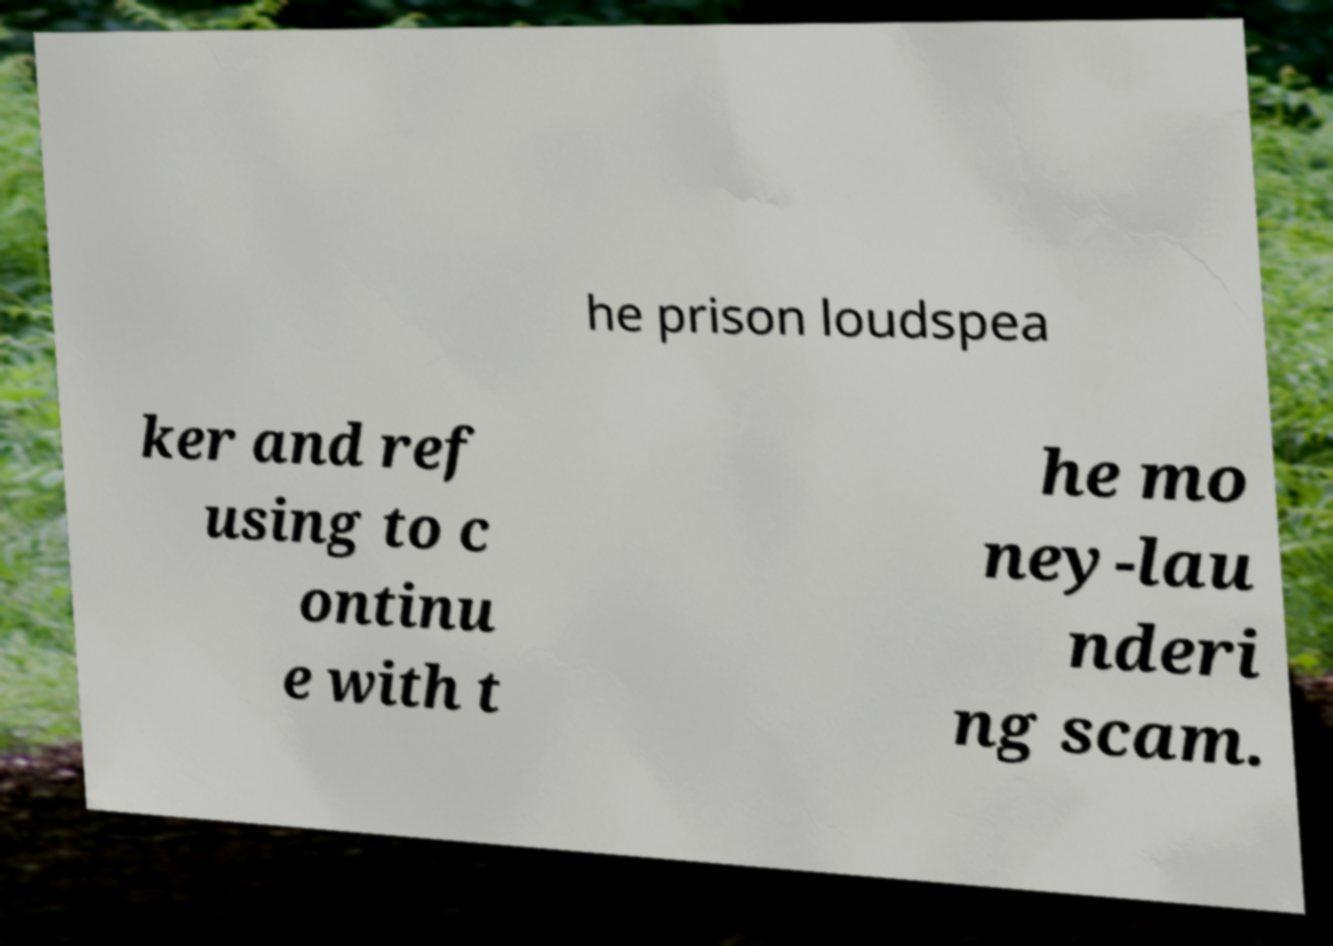What messages or text are displayed in this image? I need them in a readable, typed format. he prison loudspea ker and ref using to c ontinu e with t he mo ney-lau nderi ng scam. 